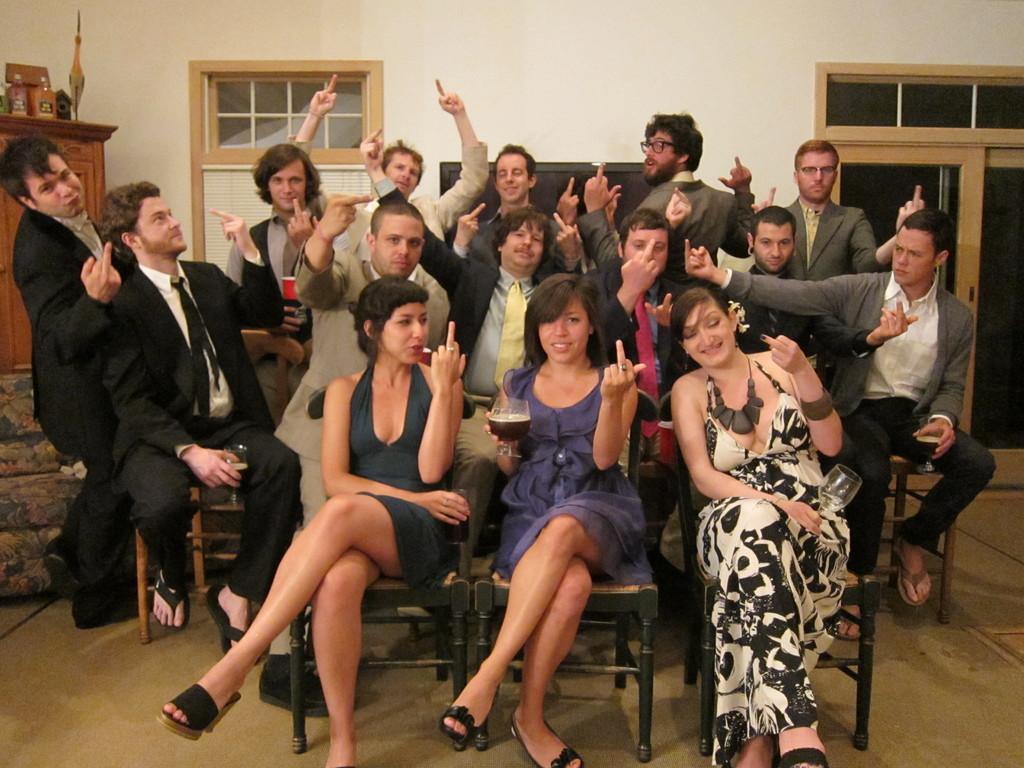Can you describe this image briefly? In the middle of this image, there are women and men showing their middle fingers. Some of them are sitting on the chairs, which are arranged on the floor. In the background, there are bottles and other objects on a wooden cupboard, there are doors, windows and a white wall. 